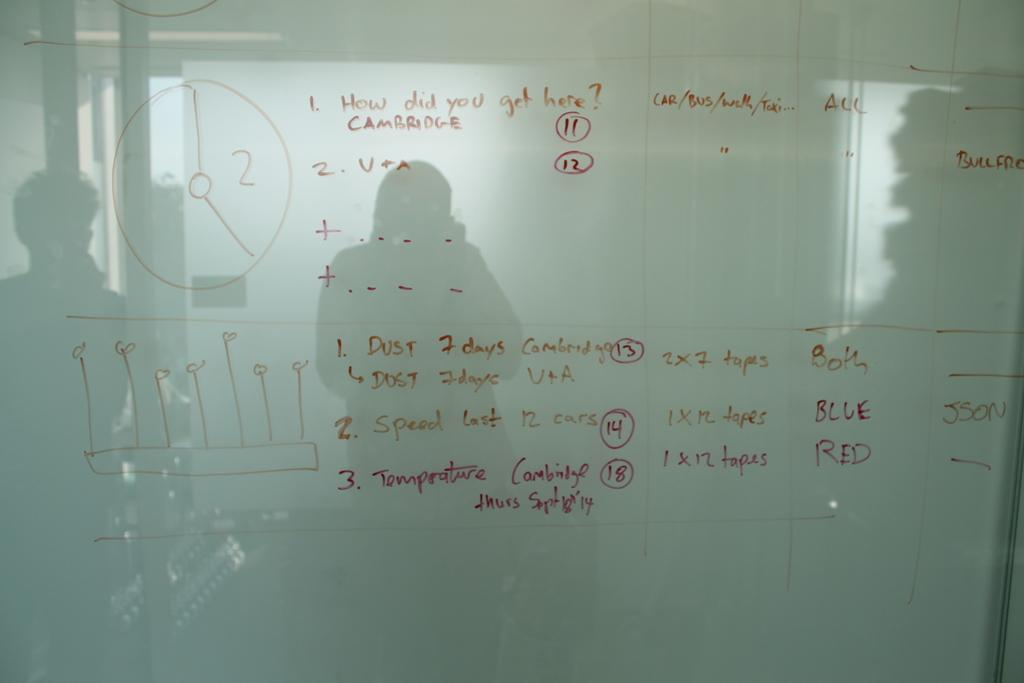<image>
Summarize the visual content of the image. White board which says "How did you get here?". 